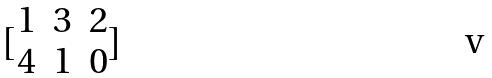Convert formula to latex. <formula><loc_0><loc_0><loc_500><loc_500>[ \begin{matrix} 1 & 3 & 2 \\ 4 & 1 & 0 \end{matrix} ]</formula> 